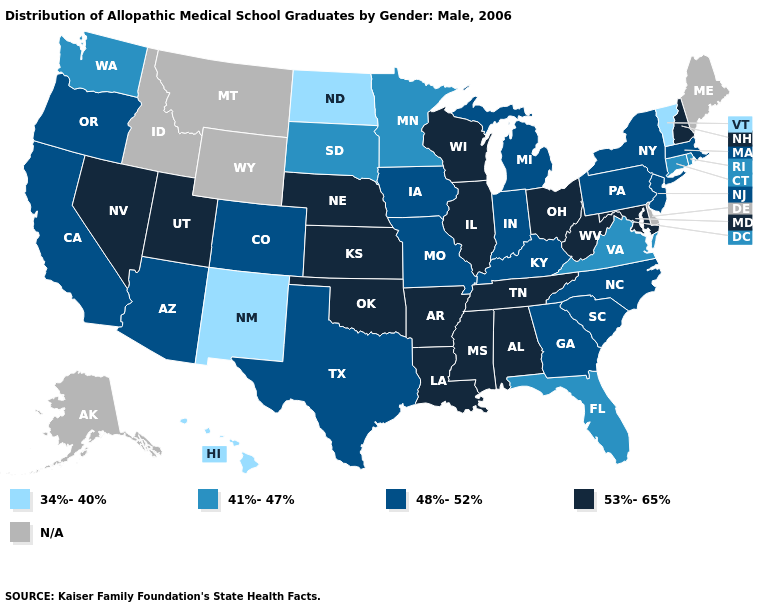What is the value of Maine?
Give a very brief answer. N/A. Which states have the lowest value in the USA?
Keep it brief. Hawaii, New Mexico, North Dakota, Vermont. Name the states that have a value in the range N/A?
Be succinct. Alaska, Delaware, Idaho, Maine, Montana, Wyoming. Which states have the lowest value in the South?
Give a very brief answer. Florida, Virginia. What is the highest value in the West ?
Concise answer only. 53%-65%. Name the states that have a value in the range 34%-40%?
Keep it brief. Hawaii, New Mexico, North Dakota, Vermont. Name the states that have a value in the range 53%-65%?
Concise answer only. Alabama, Arkansas, Illinois, Kansas, Louisiana, Maryland, Mississippi, Nebraska, Nevada, New Hampshire, Ohio, Oklahoma, Tennessee, Utah, West Virginia, Wisconsin. What is the lowest value in the MidWest?
Quick response, please. 34%-40%. Name the states that have a value in the range 41%-47%?
Be succinct. Connecticut, Florida, Minnesota, Rhode Island, South Dakota, Virginia, Washington. Which states have the highest value in the USA?
Write a very short answer. Alabama, Arkansas, Illinois, Kansas, Louisiana, Maryland, Mississippi, Nebraska, Nevada, New Hampshire, Ohio, Oklahoma, Tennessee, Utah, West Virginia, Wisconsin. What is the value of Kentucky?
Answer briefly. 48%-52%. What is the value of Alaska?
Concise answer only. N/A. Among the states that border Illinois , does Wisconsin have the lowest value?
Short answer required. No. Name the states that have a value in the range 41%-47%?
Concise answer only. Connecticut, Florida, Minnesota, Rhode Island, South Dakota, Virginia, Washington. What is the value of Utah?
Short answer required. 53%-65%. 